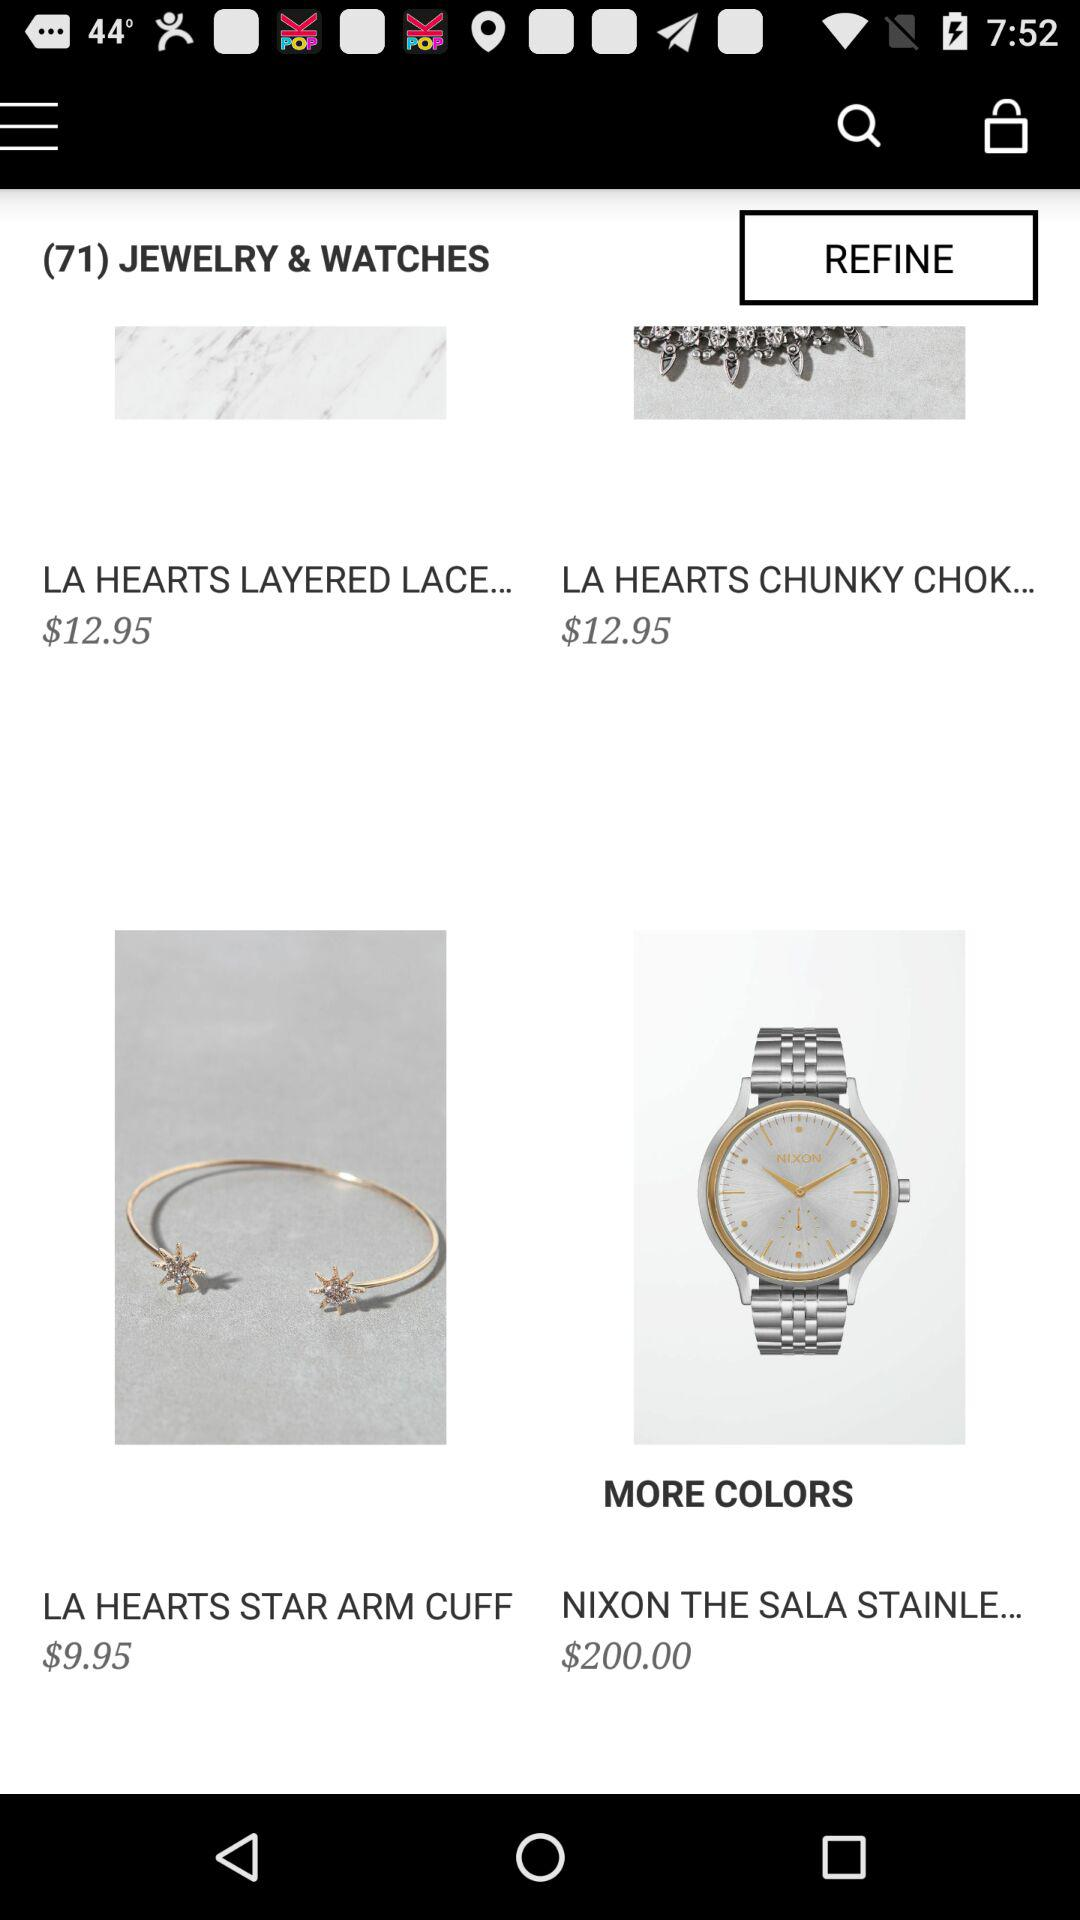How many items are there in the search results?
Answer the question using a single word or phrase. 4 